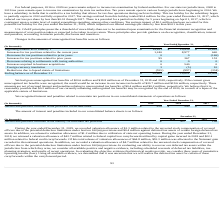According to Allscripts Healthcare Solutions's financial document, How much is the gross unrecognized tax benefits as of December 31, 2019? According to the financial document, $20.6 million. The relevant text states: "We had gross unrecognized tax benefits of $20.6 million and $19.8 million as of December 31, 2019 and 2018, respectively. If the current gross..." Also, How much is the gross unrecognized tax benefits as of December 31, 2018? According to the financial document, $19.8 million. The relevant text states: "oss unrecognized tax benefits of $20.6 million and $19.8 million as of December 31, 2019 and 2018, respectively. If the current gross..." Also, What would have been the impact if the current gross unrecognized tax benefits were recognized? the result would be an increase in our income tax benefit of $20.7 million and $19.6 million, respectively.. The document states: "unrecognized tax benefits were recognized, the result would be an increase in our income tax benefit of $20.7 million and $19.6 million, respectively...." Also, can you calculate: What is the change in Beginning balance as of January 1 between 2019 and 2018? Based on the calculation: 19,821-10,939, the result is 8882 (in thousands). This is based on the information: "Beginning balance as of January 1 $ 19,821 $ 10,939 $ 10,616 Beginning balance as of January 1 $ 19,821 $ 10,939 $ 10,616..." The key data points involved are: 10,939, 19,821. Also, can you calculate: What is the change in Increases for tax positions related to the current year between 2019 and 2018? Based on the calculation: 1,240-8,977, the result is -7737 (in thousands). This is based on the information: "ses for tax positions related to the current year 1,240 8,977 640 r tax positions related to the current year 1,240 8,977 640..." The key data points involved are: 1,240, 8,977. Also, can you calculate: What is the change in Increases for tax positions related to prior years between 2019 and 2018? Based on the calculation: 95-367, the result is -272 (in thousands). This is based on the information: "eases for tax positions related to prior years 95 367 153 ncreases for tax positions related to prior years 95 367 153..." The key data points involved are: 367, 95. 